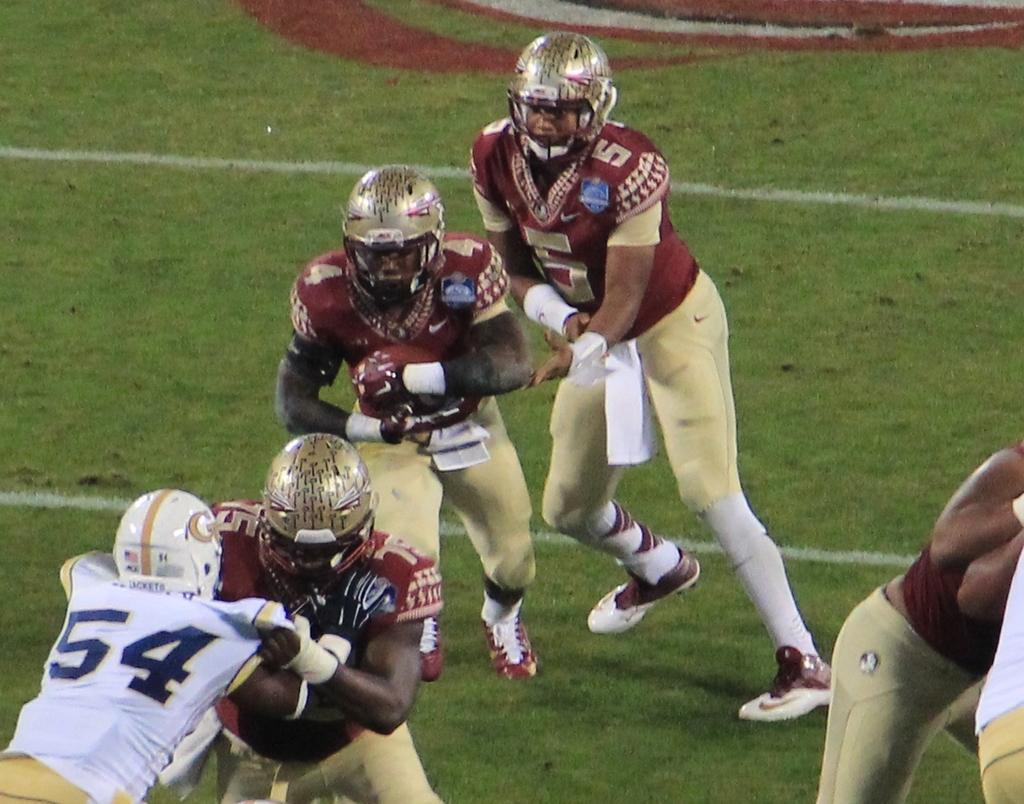How many people are in the image? There are multiple persons in the image. What activity are the persons engaged in? The persons are playing American football. What is the surface they are playing on? There is green grass at the bottom of the image. What protective gear are the persons wearing? The persons are wearing helmets. Is there a letter visible on the grass in the image? There is no letter visible on the grass in the image; it only shows persons playing American football on green grass. Is it raining in the image? The image does not show any indication of rain; it only shows persons playing American football on green grass. 